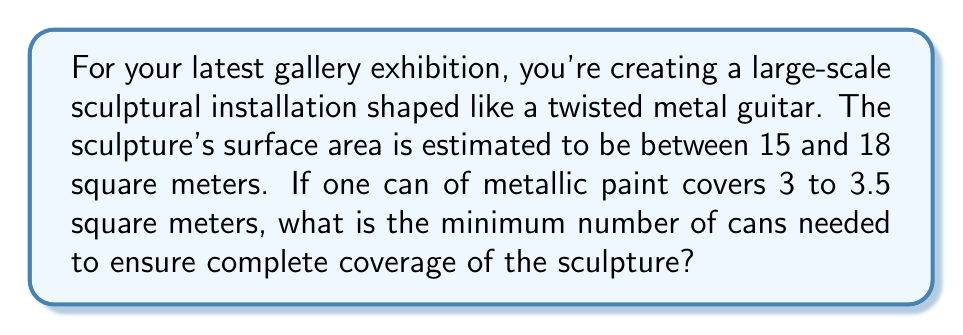Could you help me with this problem? To solve this problem, we need to consider the worst-case scenario:
1) Maximum surface area to cover: 18 m²
2) Minimum coverage per can: 3 m²

Let's set up the inequality:
$$ 3x \geq 18 $$
Where $x$ is the number of cans needed.

Solving for $x$:
$$ x \geq \frac{18}{3} = 6 $$

Since we can only use whole cans of paint, we need to round up to the nearest integer.

Therefore, the minimum number of cans needed is 6.

To verify:
- 6 cans at minimum coverage: $6 \times 3 = 18$ m²
This exactly covers the maximum possible surface area.

With 5 cans:
$$ 5 \times 3.5 = 17.5 \text{ m²} $$
This might not be enough if the surface area is indeed 18 m².
Answer: 6 cans 